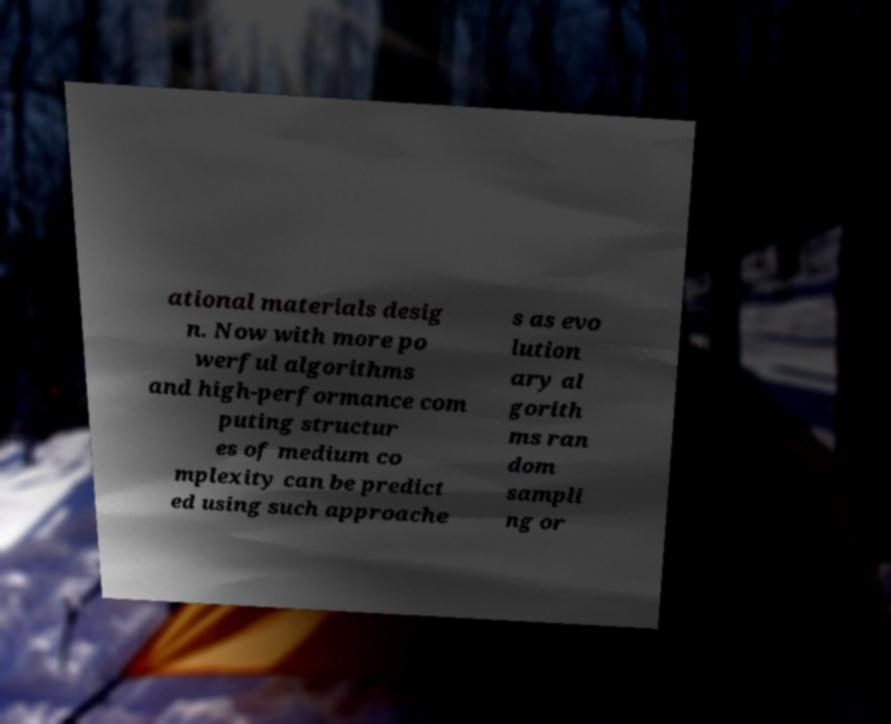What messages or text are displayed in this image? I need them in a readable, typed format. ational materials desig n. Now with more po werful algorithms and high-performance com puting structur es of medium co mplexity can be predict ed using such approache s as evo lution ary al gorith ms ran dom sampli ng or 